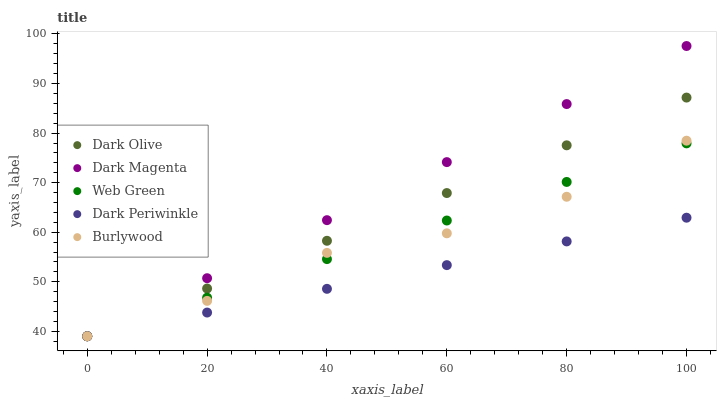Does Dark Periwinkle have the minimum area under the curve?
Answer yes or no. Yes. Does Dark Magenta have the maximum area under the curve?
Answer yes or no. Yes. Does Dark Olive have the minimum area under the curve?
Answer yes or no. No. Does Dark Olive have the maximum area under the curve?
Answer yes or no. No. Is Dark Magenta the smoothest?
Answer yes or no. Yes. Is Burlywood the roughest?
Answer yes or no. Yes. Is Dark Olive the smoothest?
Answer yes or no. No. Is Dark Olive the roughest?
Answer yes or no. No. Does Burlywood have the lowest value?
Answer yes or no. Yes. Does Dark Magenta have the highest value?
Answer yes or no. Yes. Does Dark Olive have the highest value?
Answer yes or no. No. Does Dark Olive intersect Dark Periwinkle?
Answer yes or no. Yes. Is Dark Olive less than Dark Periwinkle?
Answer yes or no. No. Is Dark Olive greater than Dark Periwinkle?
Answer yes or no. No. 